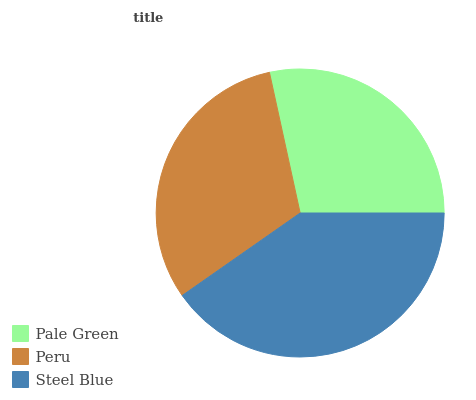Is Pale Green the minimum?
Answer yes or no. Yes. Is Steel Blue the maximum?
Answer yes or no. Yes. Is Peru the minimum?
Answer yes or no. No. Is Peru the maximum?
Answer yes or no. No. Is Peru greater than Pale Green?
Answer yes or no. Yes. Is Pale Green less than Peru?
Answer yes or no. Yes. Is Pale Green greater than Peru?
Answer yes or no. No. Is Peru less than Pale Green?
Answer yes or no. No. Is Peru the high median?
Answer yes or no. Yes. Is Peru the low median?
Answer yes or no. Yes. Is Pale Green the high median?
Answer yes or no. No. Is Pale Green the low median?
Answer yes or no. No. 